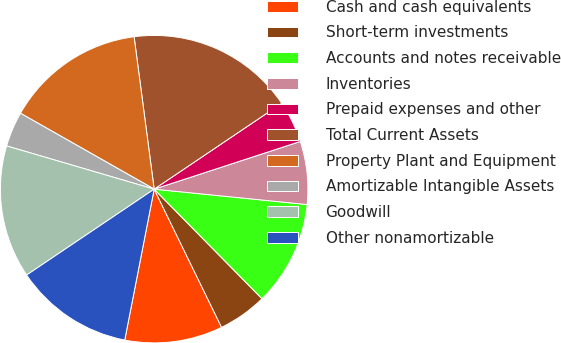<chart> <loc_0><loc_0><loc_500><loc_500><pie_chart><fcel>Cash and cash equivalents<fcel>Short-term investments<fcel>Accounts and notes receivable<fcel>Inventories<fcel>Prepaid expenses and other<fcel>Total Current Assets<fcel>Property Plant and Equipment<fcel>Amortizable Intangible Assets<fcel>Goodwill<fcel>Other nonamortizable<nl><fcel>10.29%<fcel>5.15%<fcel>11.03%<fcel>6.62%<fcel>4.41%<fcel>17.65%<fcel>14.7%<fcel>3.68%<fcel>13.97%<fcel>12.5%<nl></chart> 